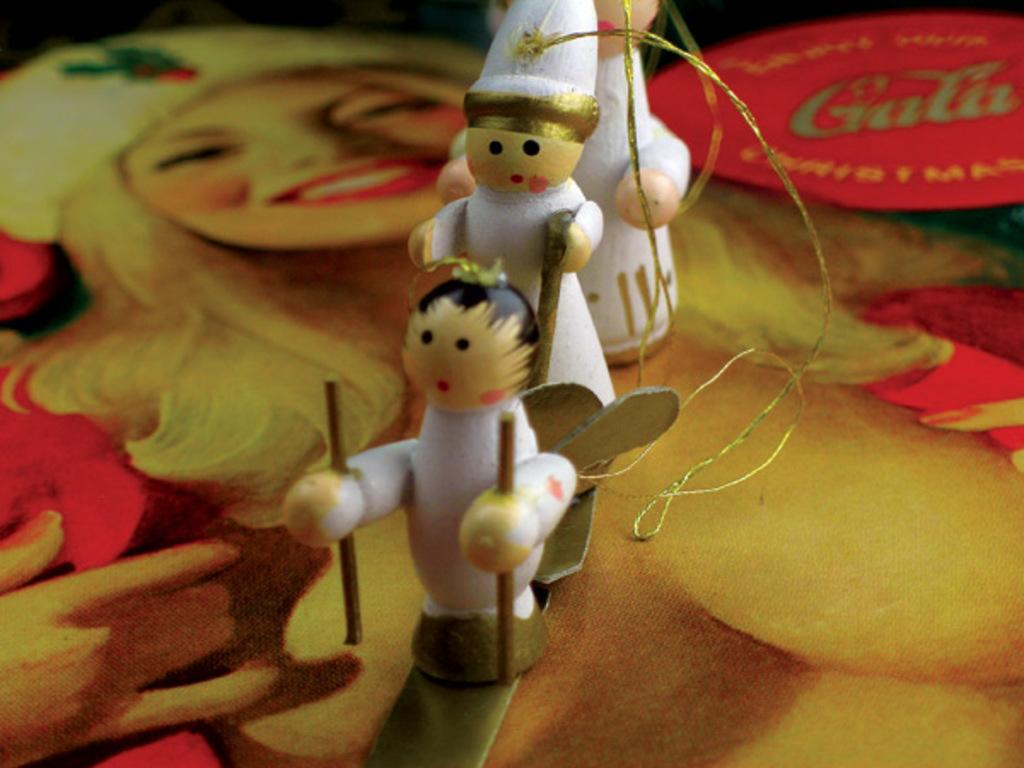What are the toys in the image made of? The toys in the image are made of white color material. How many toys can be seen in the image? There are three toys in the image. What is happening in the background of the image? There is a woman painting in the background of the image. Can you see any hills covered in sleet in the image? There are no hills or sleet present in the image; it features three white color toys and a woman painting in the background. Is there a nest visible in the image? There is no nest present in the image. 